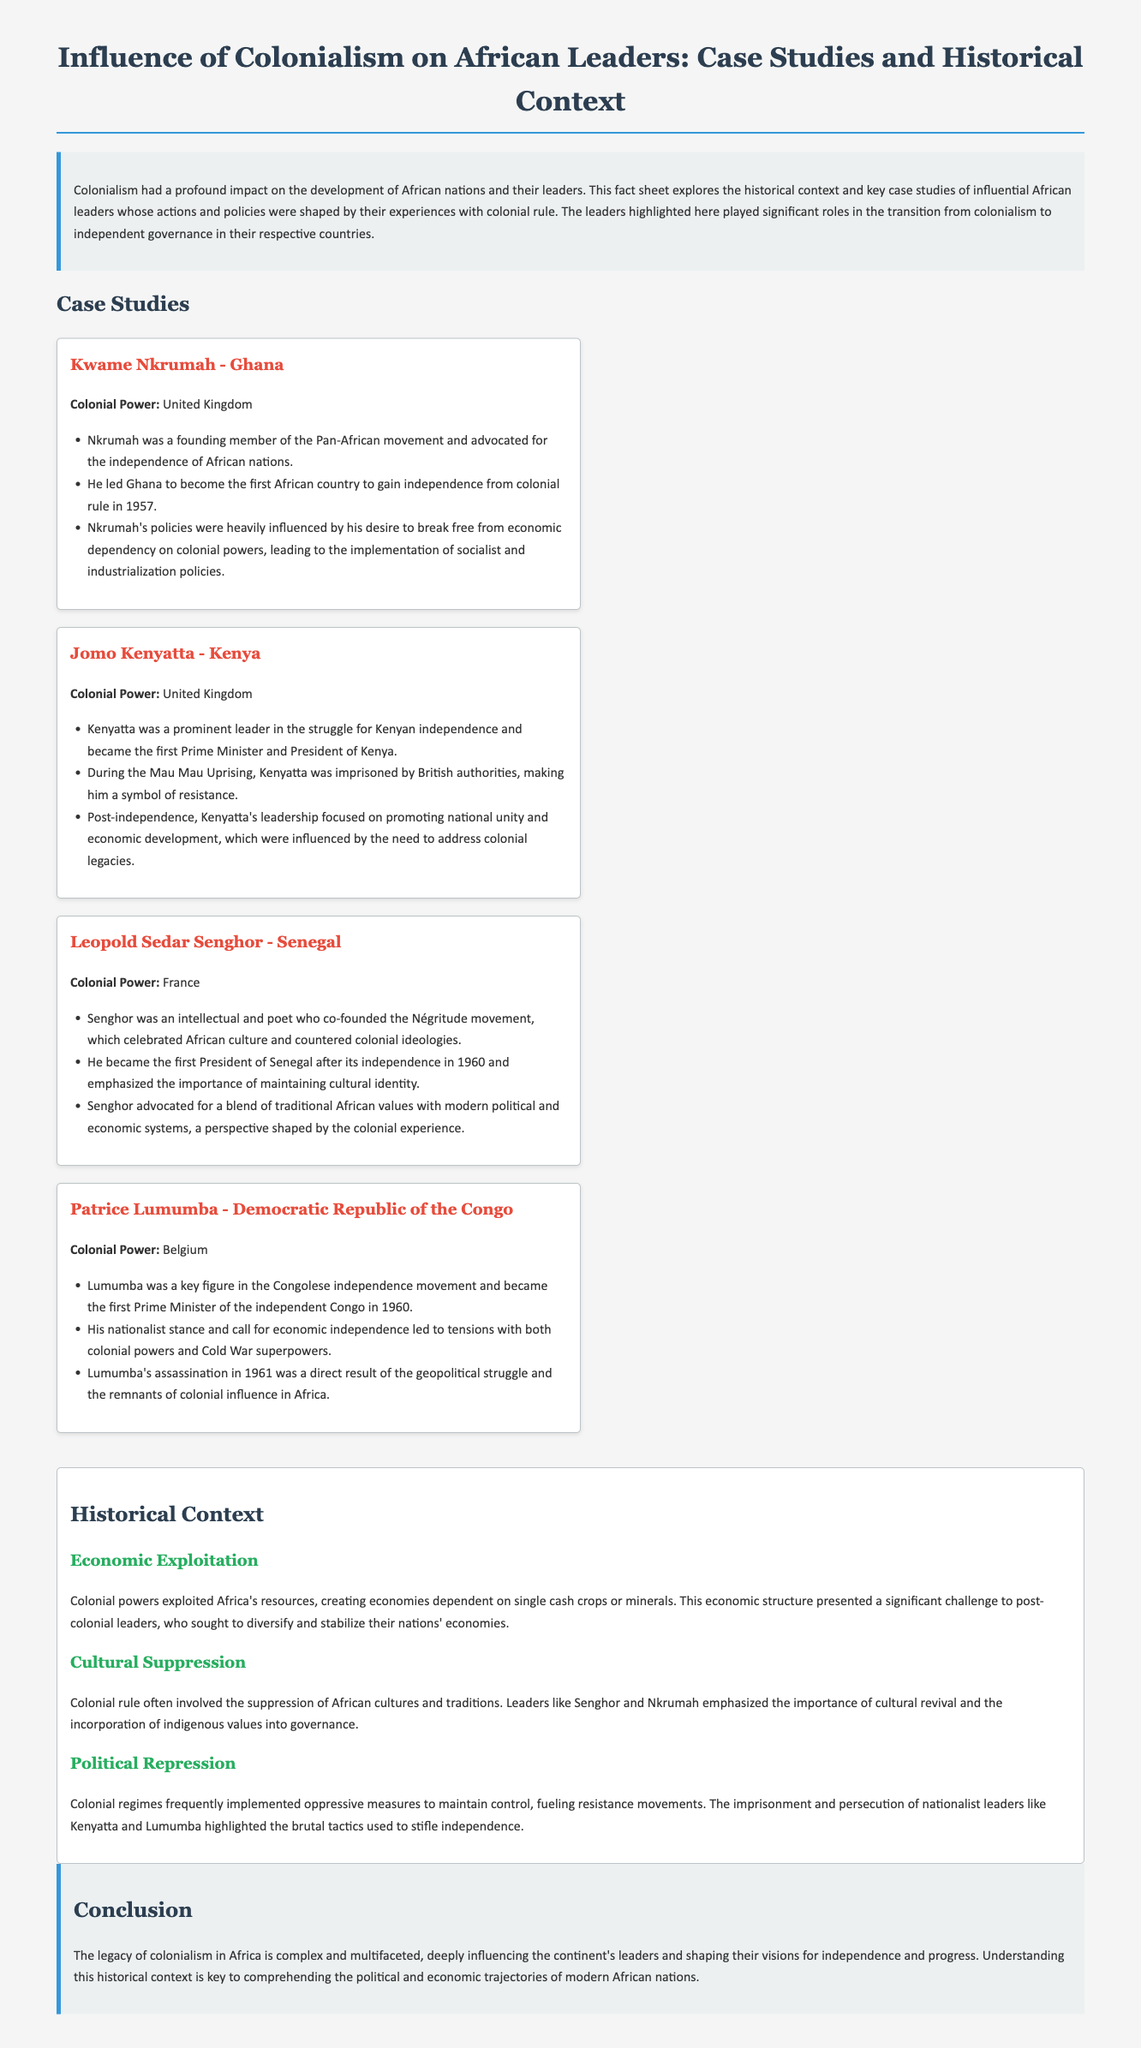What is the title of the document? The title is prominently displayed at the top, encapsulating the main theme of the content.
Answer: Influence of Colonialism on African Leaders: Case Studies and Historical Context Who was the first President of Senegal? The document mentions Senghor as the first President of Senegal after its independence.
Answer: Leopold Sedar Senghor Which colonial power ruled Ghana? The document specifies that the colonial power in Ghana was the United Kingdom.
Answer: United Kingdom What year did Ghana gain independence? The document states that Ghana became independent in 1957.
Answer: 1957 What movement did Leopold Sedar Senghor co-found? The document refers to Senghor as a co-founder of the Négritude movement.
Answer: Négritude What was a major influence on Patrice Lumumba's leadership? The document indicates that Lumumba's leadership was influenced by the call for economic independence.
Answer: Economic independence How many case studies are presented in the document? The document lists four prominent leaders as case studies.
Answer: Four What was a challenge faced by post-colonial leaders related to economic structure? The document describes the dependence on single cash crops or minerals as a significant challenge.
Answer: Economic dependence What role did Jomo Kenyatta play during the Mau Mau Uprising? The document notes that Kenyatta was imprisoned during this uprising, symbolizing resistance.
Answer: Imprisoned 